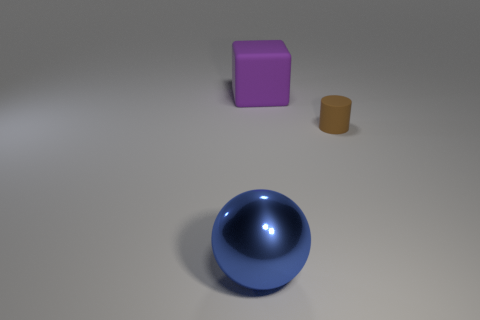Add 1 cylinders. How many objects exist? 4 Add 2 purple matte spheres. How many purple matte spheres exist? 2 Subtract 0 gray spheres. How many objects are left? 3 Subtract all cylinders. How many objects are left? 2 Subtract all gray blocks. Subtract all blue cylinders. How many blocks are left? 1 Subtract all brown things. Subtract all large rubber objects. How many objects are left? 1 Add 2 cylinders. How many cylinders are left? 3 